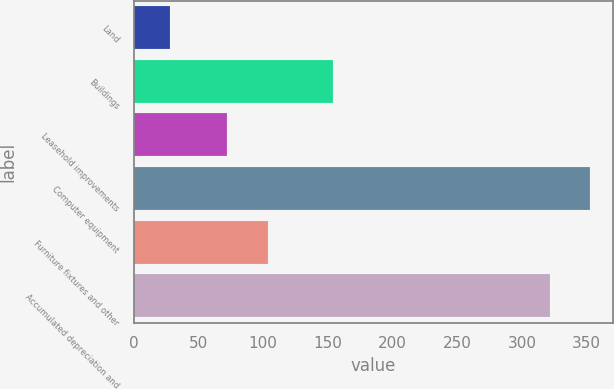Convert chart to OTSL. <chart><loc_0><loc_0><loc_500><loc_500><bar_chart><fcel>Land<fcel>Buildings<fcel>Leasehold improvements<fcel>Computer equipment<fcel>Furniture fixtures and other<fcel>Accumulated depreciation and<nl><fcel>28.2<fcel>154.3<fcel>72<fcel>352.81<fcel>103.8<fcel>321.7<nl></chart> 